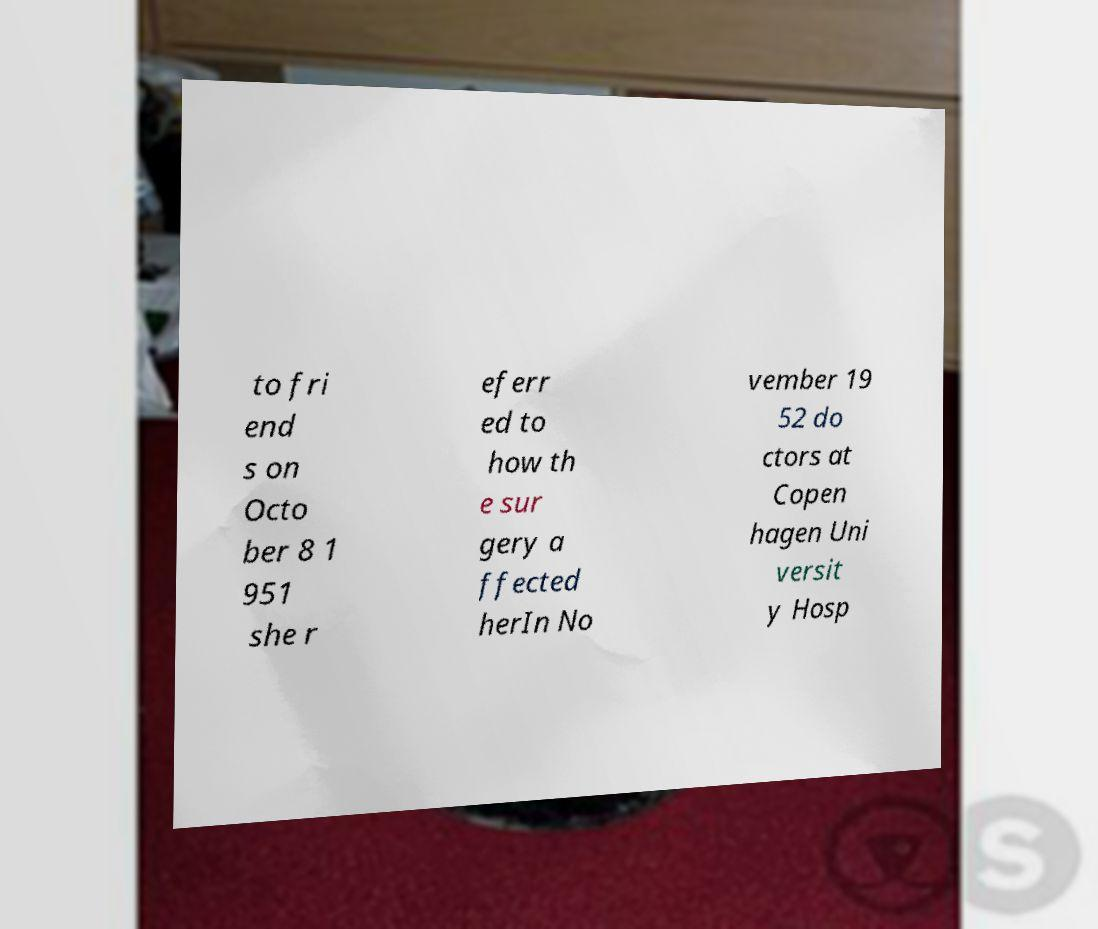Could you assist in decoding the text presented in this image and type it out clearly? to fri end s on Octo ber 8 1 951 she r eferr ed to how th e sur gery a ffected herIn No vember 19 52 do ctors at Copen hagen Uni versit y Hosp 